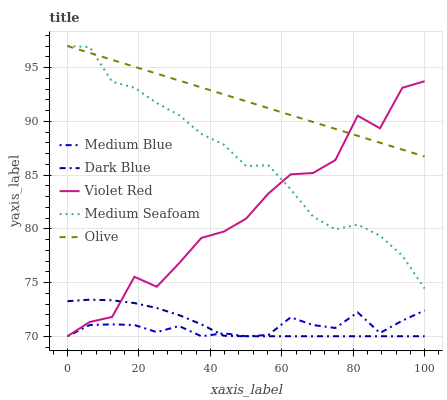Does Medium Blue have the minimum area under the curve?
Answer yes or no. Yes. Does Olive have the maximum area under the curve?
Answer yes or no. Yes. Does Dark Blue have the minimum area under the curve?
Answer yes or no. No. Does Dark Blue have the maximum area under the curve?
Answer yes or no. No. Is Olive the smoothest?
Answer yes or no. Yes. Is Violet Red the roughest?
Answer yes or no. Yes. Is Dark Blue the smoothest?
Answer yes or no. No. Is Dark Blue the roughest?
Answer yes or no. No. Does Medium Seafoam have the lowest value?
Answer yes or no. No. Does Dark Blue have the highest value?
Answer yes or no. No. Is Dark Blue less than Olive?
Answer yes or no. Yes. Is Olive greater than Medium Blue?
Answer yes or no. Yes. Does Dark Blue intersect Olive?
Answer yes or no. No. 